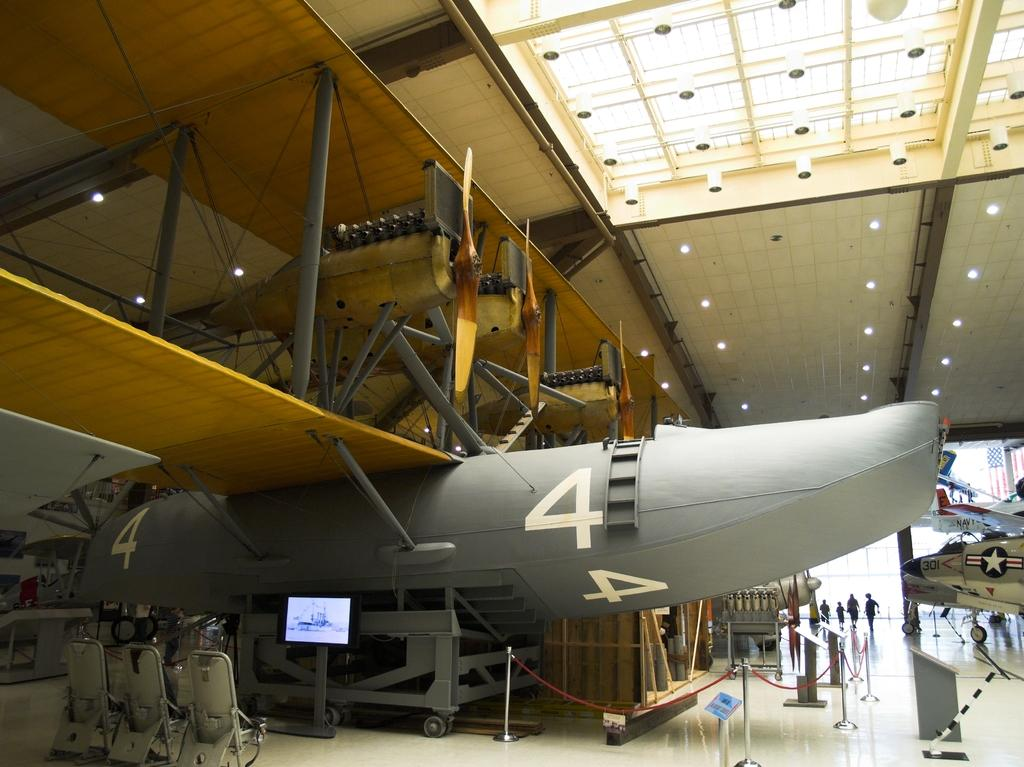<image>
Offer a succinct explanation of the picture presented. airplane parts in a builidng with a large grey one numbered 4 